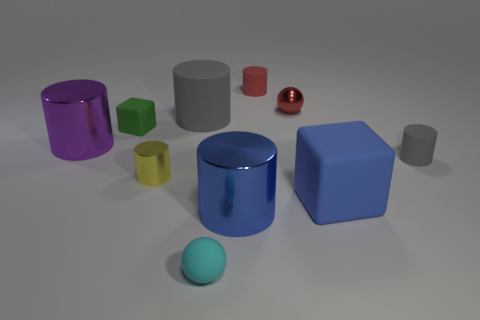Subtract all large purple cylinders. How many cylinders are left? 5 Subtract 2 spheres. How many spheres are left? 0 Subtract all yellow cylinders. How many cylinders are left? 5 Subtract all blocks. How many objects are left? 8 Subtract all red balls. Subtract all purple cubes. How many balls are left? 1 Subtract all cyan cylinders. How many gray cubes are left? 0 Subtract all big cyan matte balls. Subtract all big blue metal things. How many objects are left? 9 Add 7 yellow cylinders. How many yellow cylinders are left? 8 Add 3 big yellow blocks. How many big yellow blocks exist? 3 Subtract 0 cyan cubes. How many objects are left? 10 